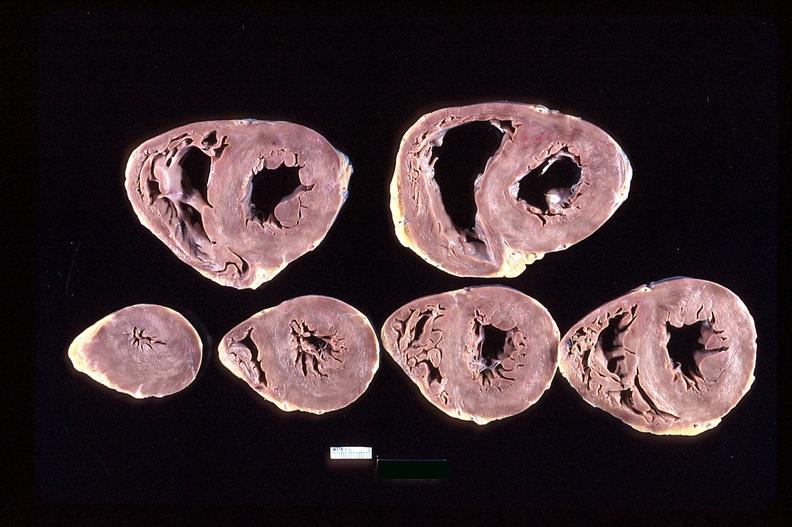where is this?
Answer the question using a single word or phrase. Heart 